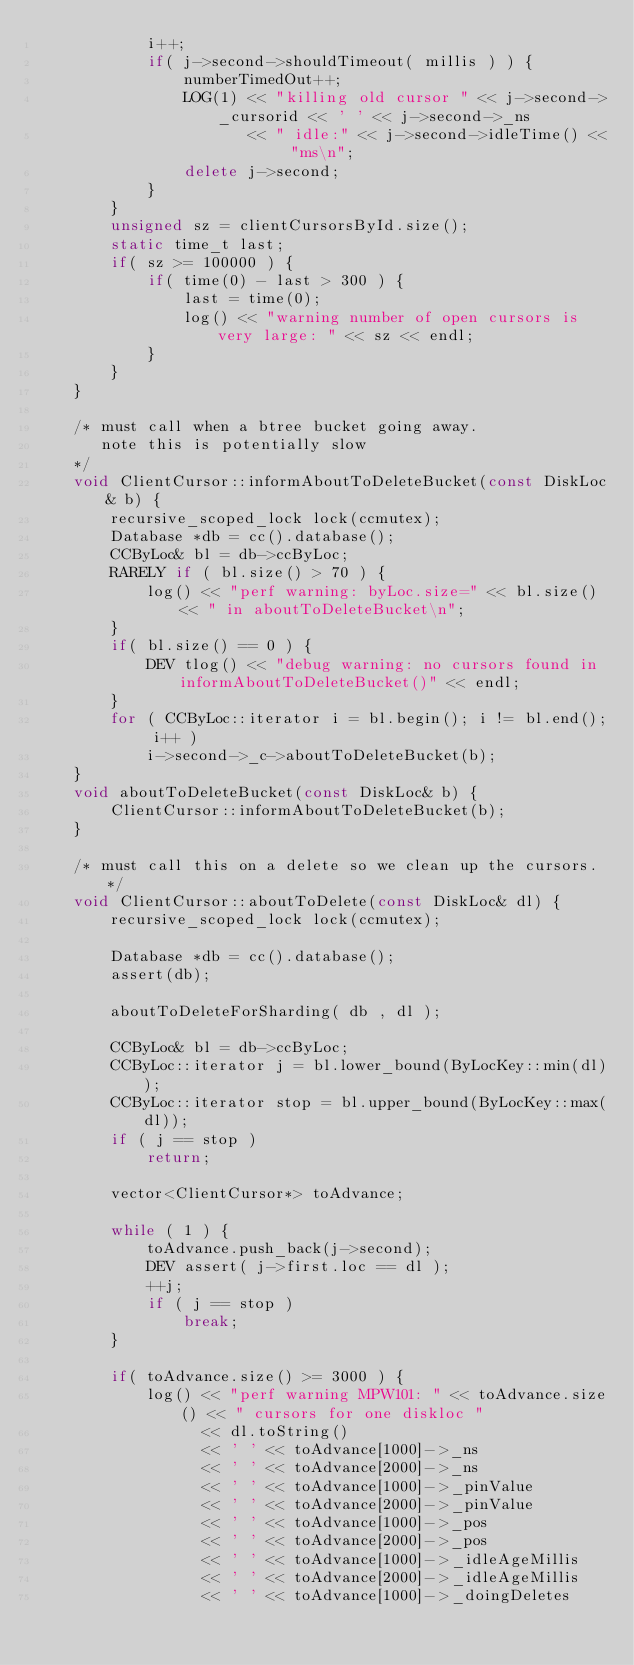<code> <loc_0><loc_0><loc_500><loc_500><_C++_>            i++;
            if( j->second->shouldTimeout( millis ) ) {
                numberTimedOut++;
                LOG(1) << "killing old cursor " << j->second->_cursorid << ' ' << j->second->_ns
                       << " idle:" << j->second->idleTime() << "ms\n";
                delete j->second;
            }
        }
        unsigned sz = clientCursorsById.size();
        static time_t last;
        if( sz >= 100000 ) { 
            if( time(0) - last > 300 ) {
                last = time(0);
                log() << "warning number of open cursors is very large: " << sz << endl;
            }
        }
    }

    /* must call when a btree bucket going away.
       note this is potentially slow
    */
    void ClientCursor::informAboutToDeleteBucket(const DiskLoc& b) {
        recursive_scoped_lock lock(ccmutex);
        Database *db = cc().database();
        CCByLoc& bl = db->ccByLoc;
        RARELY if ( bl.size() > 70 ) {
            log() << "perf warning: byLoc.size=" << bl.size() << " in aboutToDeleteBucket\n";
        }
        if( bl.size() == 0 ) { 
            DEV tlog() << "debug warning: no cursors found in informAboutToDeleteBucket()" << endl;
        }
        for ( CCByLoc::iterator i = bl.begin(); i != bl.end(); i++ )
            i->second->_c->aboutToDeleteBucket(b);
    }
    void aboutToDeleteBucket(const DiskLoc& b) {
        ClientCursor::informAboutToDeleteBucket(b);
    }

    /* must call this on a delete so we clean up the cursors. */
    void ClientCursor::aboutToDelete(const DiskLoc& dl) {
        recursive_scoped_lock lock(ccmutex);

        Database *db = cc().database();
        assert(db);

        aboutToDeleteForSharding( db , dl );

        CCByLoc& bl = db->ccByLoc;
        CCByLoc::iterator j = bl.lower_bound(ByLocKey::min(dl));
        CCByLoc::iterator stop = bl.upper_bound(ByLocKey::max(dl));
        if ( j == stop )
            return;

        vector<ClientCursor*> toAdvance;

        while ( 1 ) {
            toAdvance.push_back(j->second);
            DEV assert( j->first.loc == dl );
            ++j;
            if ( j == stop )
                break;
        }

        if( toAdvance.size() >= 3000 ) {
            log() << "perf warning MPW101: " << toAdvance.size() << " cursors for one diskloc "
                  << dl.toString()
                  << ' ' << toAdvance[1000]->_ns
                  << ' ' << toAdvance[2000]->_ns
                  << ' ' << toAdvance[1000]->_pinValue
                  << ' ' << toAdvance[2000]->_pinValue
                  << ' ' << toAdvance[1000]->_pos
                  << ' ' << toAdvance[2000]->_pos
                  << ' ' << toAdvance[1000]->_idleAgeMillis
                  << ' ' << toAdvance[2000]->_idleAgeMillis
                  << ' ' << toAdvance[1000]->_doingDeletes</code> 